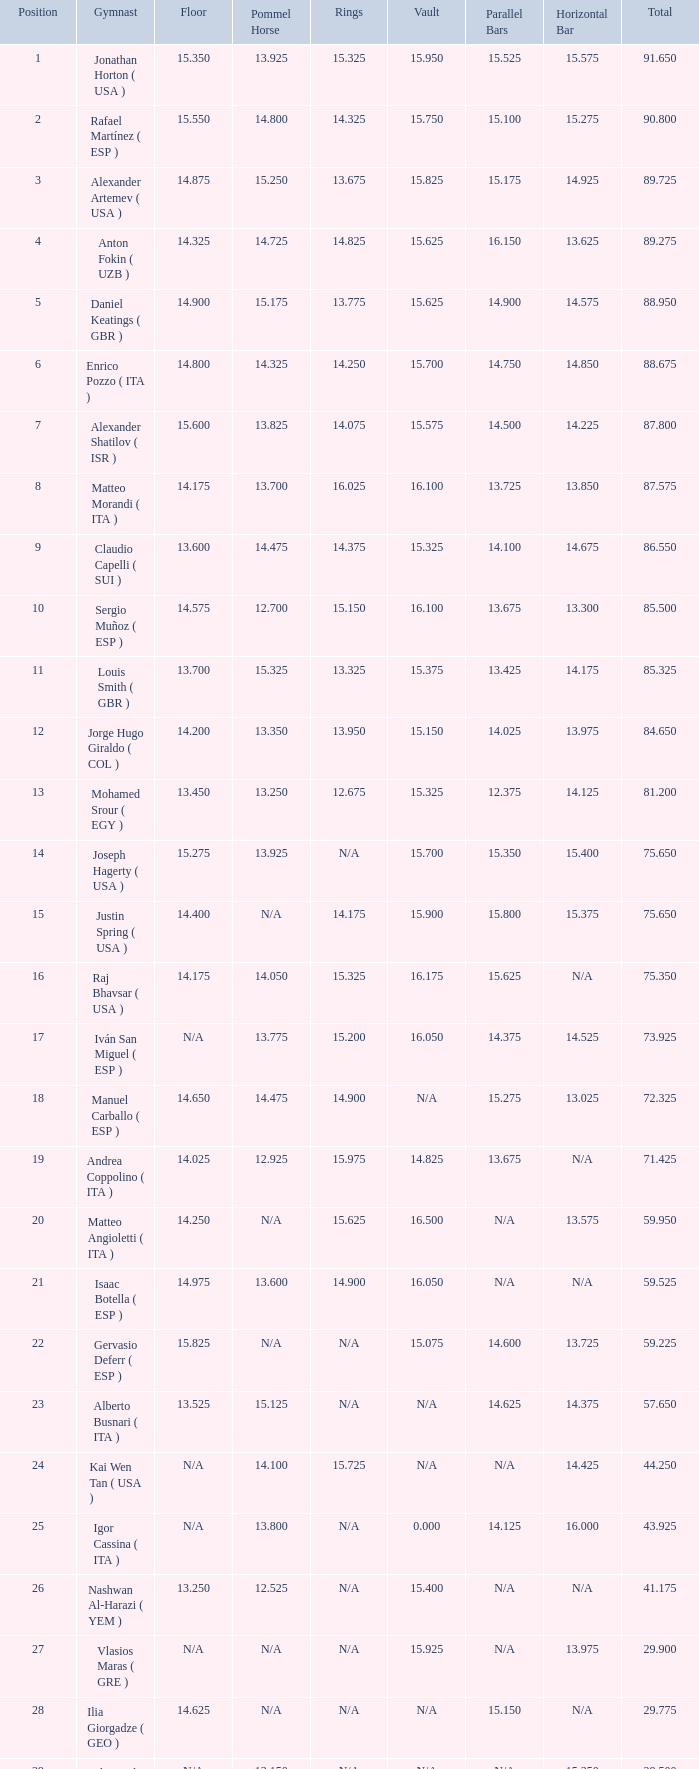If the horizontal bar is n/a and the floor is 14.175, what is the number for the parallel bars? 15.625. 